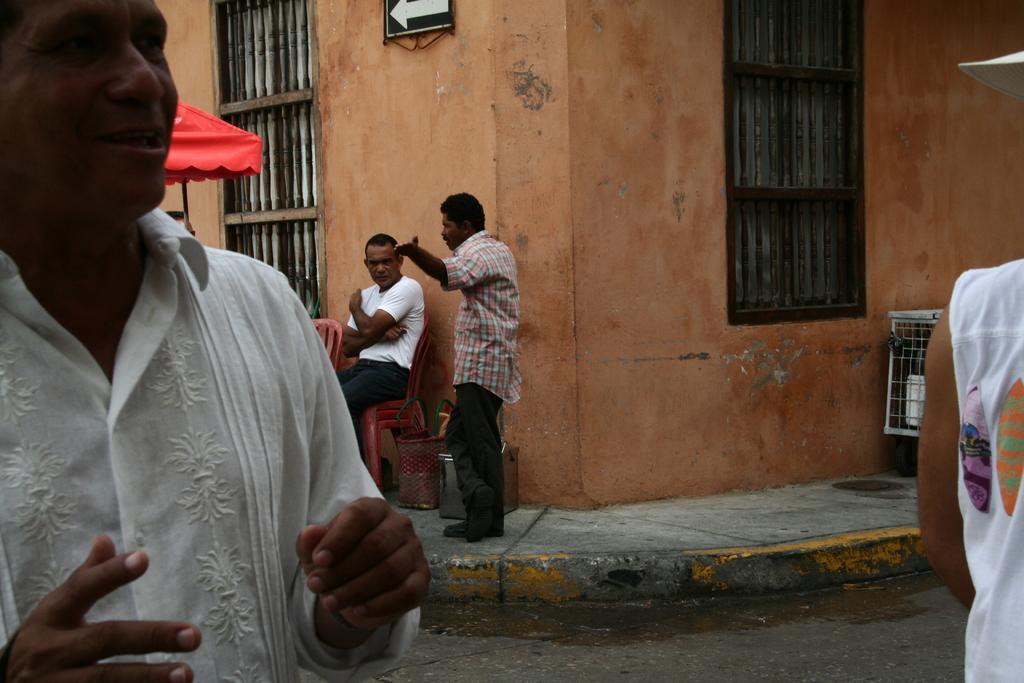Please provide a concise description of this image. In this image there is a man on the left side. In the background there is a person standing on the footpath. Beside the person there is another person who is wearing the white t-shirt is sitting on the chair. Behind them there is a building with the windows. On the footpath there is a metal box and a bag. On the left side there is a red colour tent. On the right side there is a grill on the footpath. 